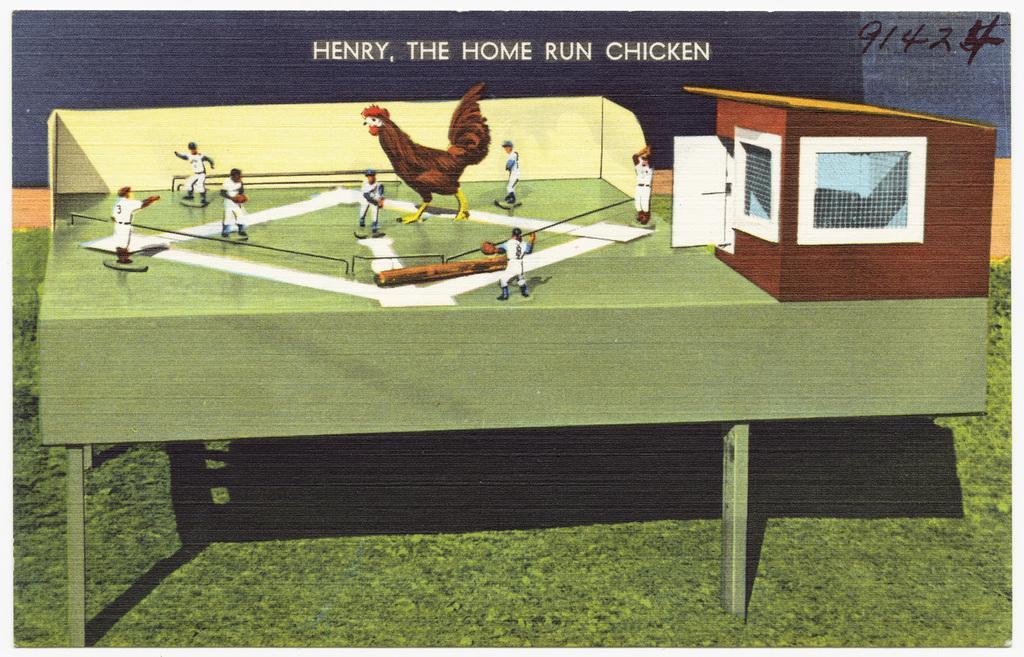How would you summarize this image in a sentence or two? In this image there is a table. On the right there is a shed. In the center there are people playing a game and there is a hen. In the background there is a wall and we can see text. At the bottom there is grass. 